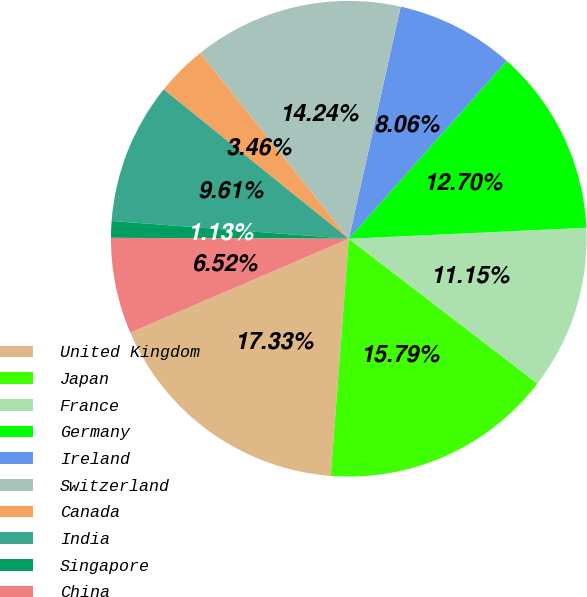<chart> <loc_0><loc_0><loc_500><loc_500><pie_chart><fcel>United Kingdom<fcel>Japan<fcel>France<fcel>Germany<fcel>Ireland<fcel>Switzerland<fcel>Canada<fcel>India<fcel>Singapore<fcel>China<nl><fcel>17.33%<fcel>15.79%<fcel>11.15%<fcel>12.7%<fcel>8.06%<fcel>14.24%<fcel>3.46%<fcel>9.61%<fcel>1.13%<fcel>6.52%<nl></chart> 